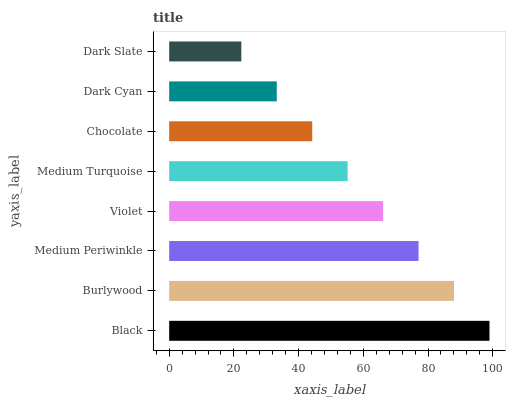Is Dark Slate the minimum?
Answer yes or no. Yes. Is Black the maximum?
Answer yes or no. Yes. Is Burlywood the minimum?
Answer yes or no. No. Is Burlywood the maximum?
Answer yes or no. No. Is Black greater than Burlywood?
Answer yes or no. Yes. Is Burlywood less than Black?
Answer yes or no. Yes. Is Burlywood greater than Black?
Answer yes or no. No. Is Black less than Burlywood?
Answer yes or no. No. Is Violet the high median?
Answer yes or no. Yes. Is Medium Turquoise the low median?
Answer yes or no. Yes. Is Medium Periwinkle the high median?
Answer yes or no. No. Is Dark Slate the low median?
Answer yes or no. No. 